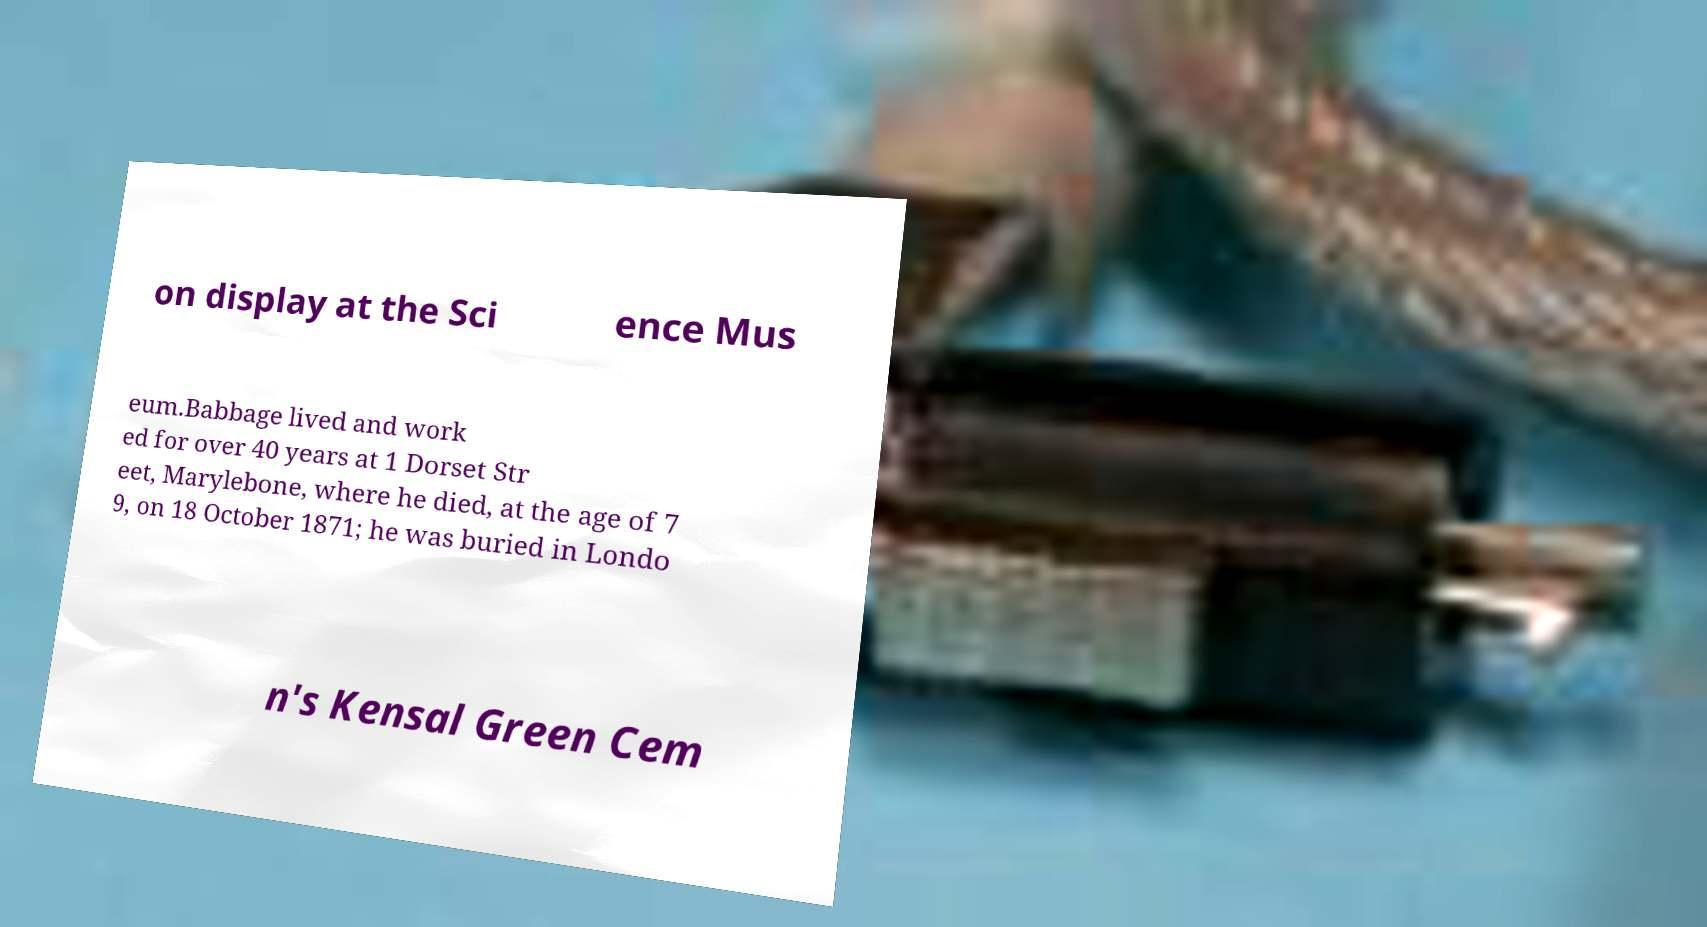Could you assist in decoding the text presented in this image and type it out clearly? on display at the Sci ence Mus eum.Babbage lived and work ed for over 40 years at 1 Dorset Str eet, Marylebone, where he died, at the age of 7 9, on 18 October 1871; he was buried in Londo n's Kensal Green Cem 